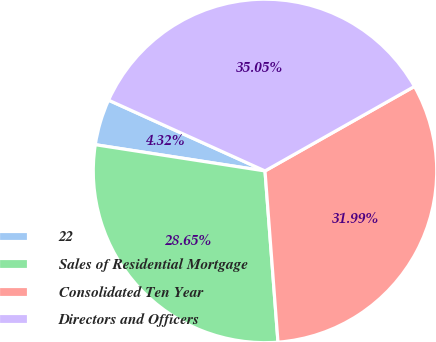Convert chart to OTSL. <chart><loc_0><loc_0><loc_500><loc_500><pie_chart><fcel>22<fcel>Sales of Residential Mortgage<fcel>Consolidated Ten Year<fcel>Directors and Officers<nl><fcel>4.32%<fcel>28.65%<fcel>31.99%<fcel>35.05%<nl></chart> 